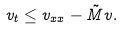Convert formula to latex. <formula><loc_0><loc_0><loc_500><loc_500>v _ { t } \leq v _ { x x } - \tilde { M } v .</formula> 